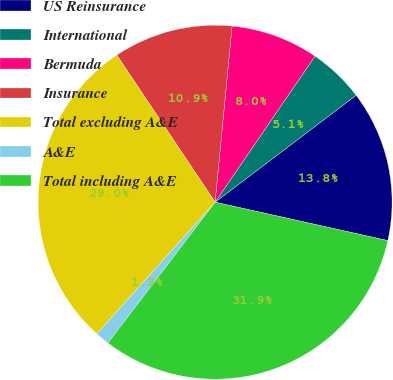Convert chart. <chart><loc_0><loc_0><loc_500><loc_500><pie_chart><fcel>US Reinsurance<fcel>International<fcel>Bermuda<fcel>Insurance<fcel>Total excluding A&E<fcel>A&E<fcel>Total including A&E<nl><fcel>13.81%<fcel>5.12%<fcel>8.02%<fcel>10.91%<fcel>28.97%<fcel>1.29%<fcel>31.87%<nl></chart> 